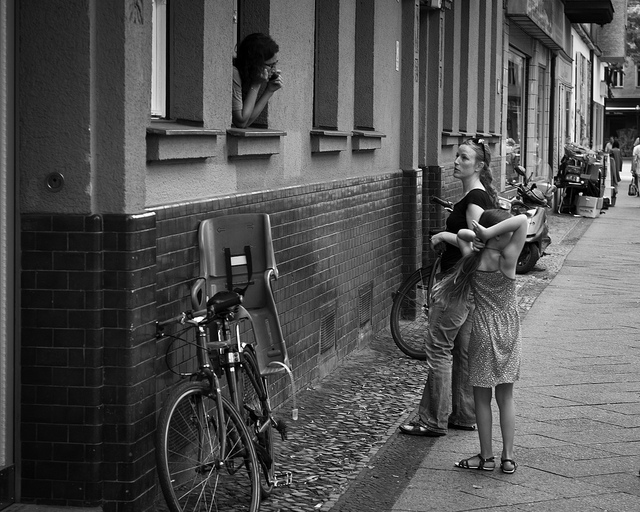<image>What kind of bottoms is the woman in the foreground wearing? I don't know what kind of bottoms the woman in the foreground is wearing. It could be jeans, pants, shorts, or a dress. What kind of bottoms is the woman in the foreground wearing? I am not sure what kind of bottoms the woman in the foreground is wearing. It can be seen jeans, pants, shorts, or dress. 